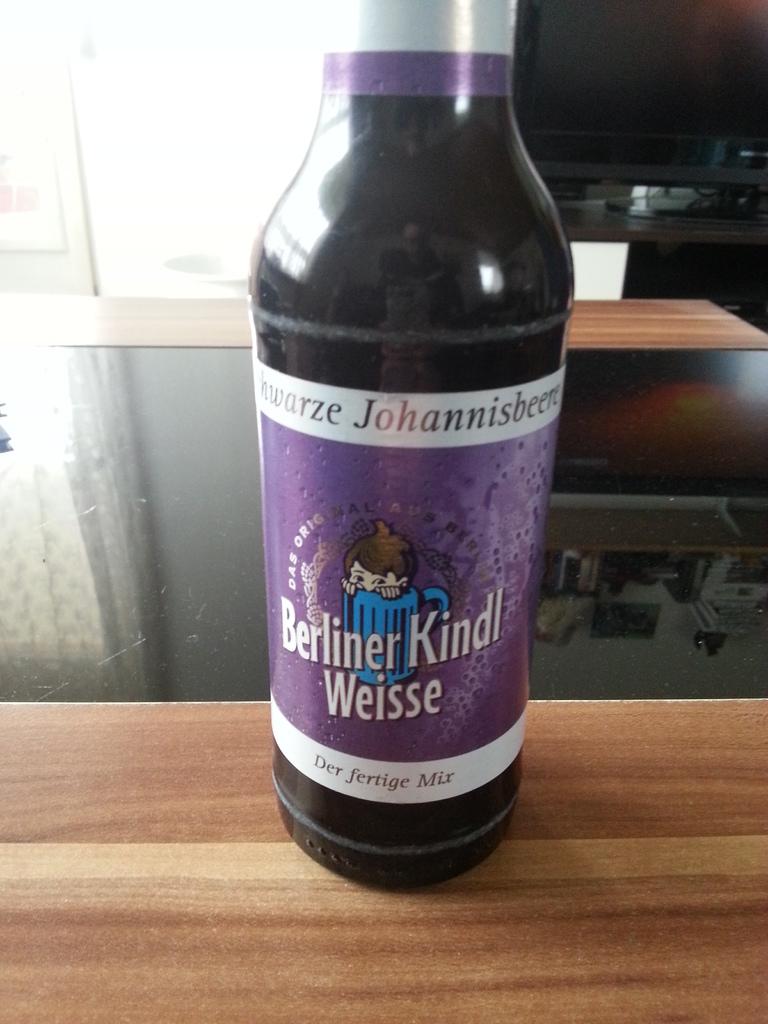What's the name of the drink?
Give a very brief answer. Berliner kindl weisse. What kind of mix is this?
Provide a short and direct response. Berliner kindl weisse. 